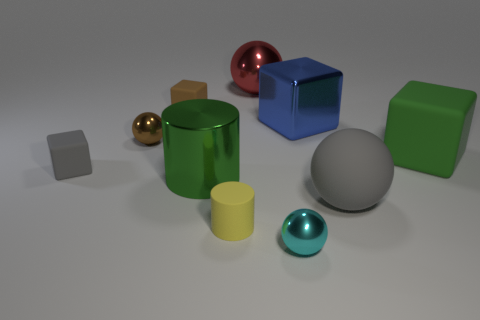There is a rubber thing that is the same color as the large cylinder; what is its shape?
Provide a short and direct response. Cube. Is the number of shiny cubes less than the number of tiny blue rubber blocks?
Ensure brevity in your answer.  No. Are there any gray rubber cubes that are behind the big rubber sphere in front of the large green cube?
Your answer should be very brief. Yes. The red object that is the same material as the small brown sphere is what shape?
Make the answer very short. Sphere. Are there any other things that have the same color as the shiny cube?
Give a very brief answer. No. There is a red object that is the same shape as the small brown metal thing; what is it made of?
Offer a very short reply. Metal. How many other objects are there of the same size as the brown sphere?
Your answer should be compact. 4. The shiny cylinder that is the same color as the big matte block is what size?
Keep it short and to the point. Large. Is the shape of the big green thing to the left of the big metallic cube the same as  the tiny yellow object?
Your answer should be compact. Yes. What number of other objects are the same shape as the red thing?
Ensure brevity in your answer.  3. 